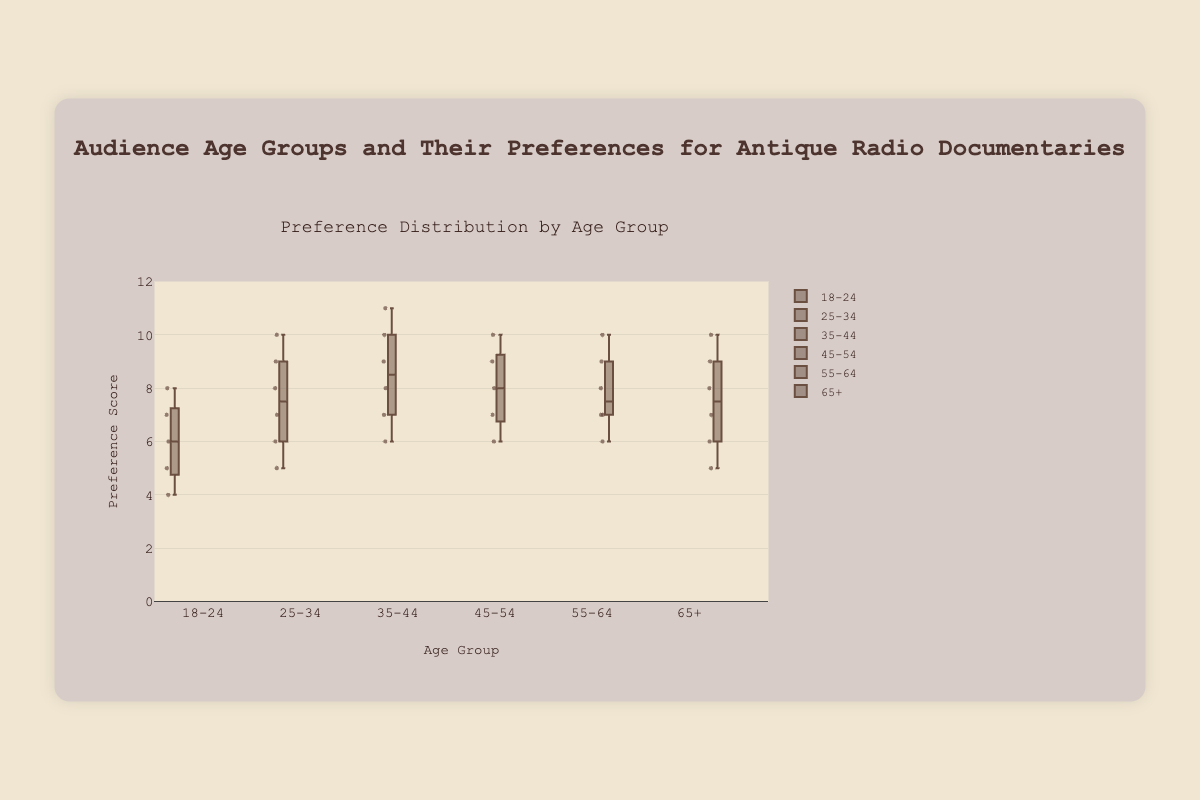What is the title of the box plot? The title of the box plot is prominently displayed at the top of the figure in a larger font size, indicating the subject of the visualization.
Answer: Audience Age Groups and Their Preferences for Antique Radio Documentaries What is the range of the y-axis? The range on the y-axis is indicated by the numerical values marking the lower and upper limits, shown as numbers alongside the axis.
Answer: 0 to 12 Which age group has the widest interquartile range (IQR)? The interquartile range (IQR) is the distance between the first quartile (Q1) and the third quartile (Q3). The age group with the widest box has the largest IQR.
Answer: 35-44 Which age group has the highest median preference score? The median is the line inside the box for each age group. The age group whose box plot has the highest median line indicates the highest median preference score.
Answer: 35-44 How many age groups have a median preference score of 8 or higher? Check the median line inside the box plot for each age group. Count the number of age groups with a median line at or above the 8 mark on the y-axis.
Answer: 4 Which age group has the smallest range in preference scores? The range is the distance between the minimum and maximum values. The age group with the shortest vertical distance between the whiskers has the smallest range.
Answer: 18-24 Compare the maximum preference score for the age groups 45-54 and 65+. Which age group has the higher maximum score? The maximum score is the top whisker for each age group. Compare the maximum scores indicated by the top whisker of the box plot for both age groups.
Answer: 45-54 What is the median preference score for the age group 65+? The median is represented by the line inside the box for each age group. For the age group 65+, this line gives the median score.
Answer: 8 Which age group has the lowest minimum preference score? The minimum score is the bottom whisker for each age group. Identify the age group whose bottom whisker is lowest on the y-axis.
Answer: 18-24 Are there any age groups with outliers in preference scores? Outliers are dots outside the range of the whiskers in a box plot. Check for any dots placed away from the main body of the box plot for each age group.
Answer: No 